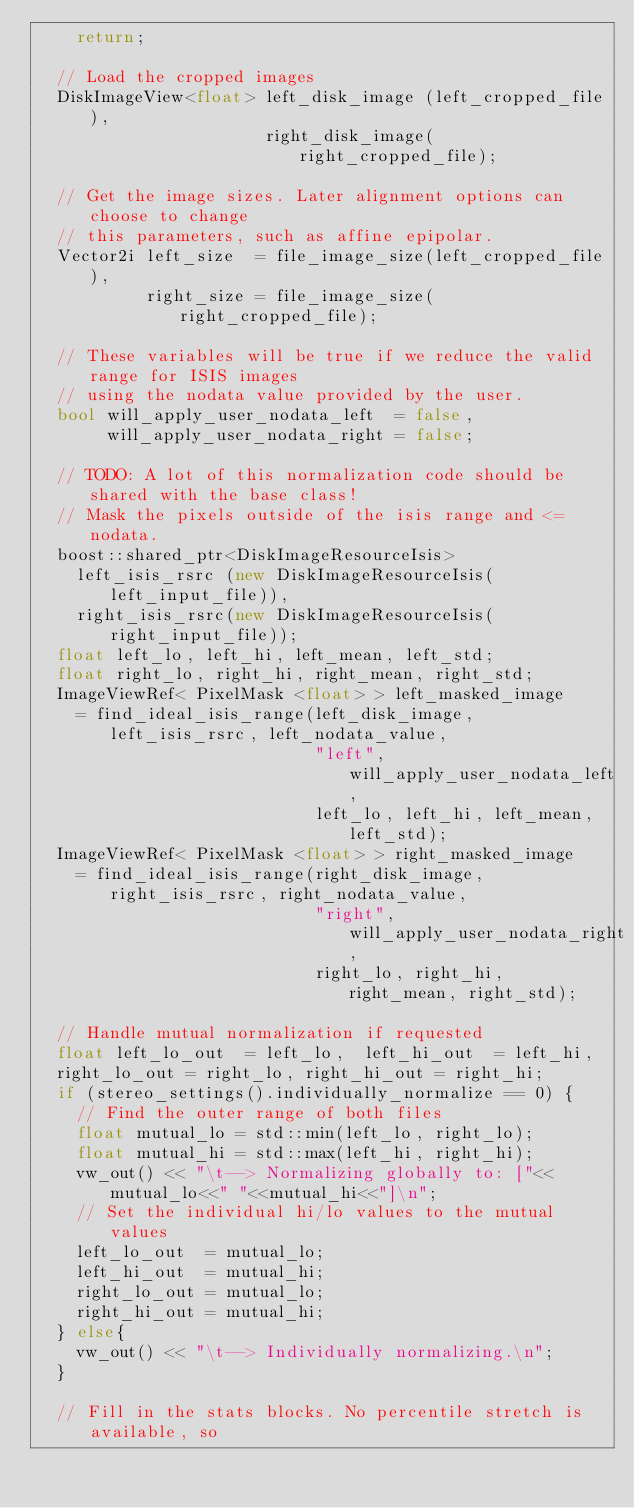Convert code to text. <code><loc_0><loc_0><loc_500><loc_500><_C++_>    return;

  // Load the cropped images
  DiskImageView<float> left_disk_image (left_cropped_file),
                       right_disk_image(right_cropped_file);

  // Get the image sizes. Later alignment options can choose to change
  // this parameters, such as affine epipolar.
  Vector2i left_size  = file_image_size(left_cropped_file),
           right_size = file_image_size(right_cropped_file);

  // These variables will be true if we reduce the valid range for ISIS images
  // using the nodata value provided by the user.
  bool will_apply_user_nodata_left  = false,
       will_apply_user_nodata_right = false;

  // TODO: A lot of this normalization code should be shared with the base class!
  // Mask the pixels outside of the isis range and <= nodata.
  boost::shared_ptr<DiskImageResourceIsis>
    left_isis_rsrc (new DiskImageResourceIsis(left_input_file)),
    right_isis_rsrc(new DiskImageResourceIsis(right_input_file));
  float left_lo, left_hi, left_mean, left_std;
  float right_lo, right_hi, right_mean, right_std;
  ImageViewRef< PixelMask <float> > left_masked_image
    = find_ideal_isis_range(left_disk_image, left_isis_rsrc, left_nodata_value,
                            "left", will_apply_user_nodata_left,
                            left_lo, left_hi, left_mean, left_std);
  ImageViewRef< PixelMask <float> > right_masked_image
    = find_ideal_isis_range(right_disk_image, right_isis_rsrc, right_nodata_value,
                            "right", will_apply_user_nodata_right,
                            right_lo, right_hi, right_mean, right_std);

  // Handle mutual normalization if requested
  float left_lo_out  = left_lo,  left_hi_out  = left_hi,
	right_lo_out = right_lo, right_hi_out = right_hi;
  if (stereo_settings().individually_normalize == 0) {
    // Find the outer range of both files
    float mutual_lo = std::min(left_lo, right_lo);
    float mutual_hi = std::max(left_hi, right_hi);
    vw_out() << "\t--> Normalizing globally to: ["<<mutual_lo<<" "<<mutual_hi<<"]\n";
    // Set the individual hi/lo values to the mutual values
    left_lo_out  = mutual_lo;
    left_hi_out  = mutual_hi;
    right_lo_out = mutual_lo;
    right_hi_out = mutual_hi;
  } else{
    vw_out() << "\t--> Individually normalizing.\n";
  }

  // Fill in the stats blocks. No percentile stretch is available, so</code> 